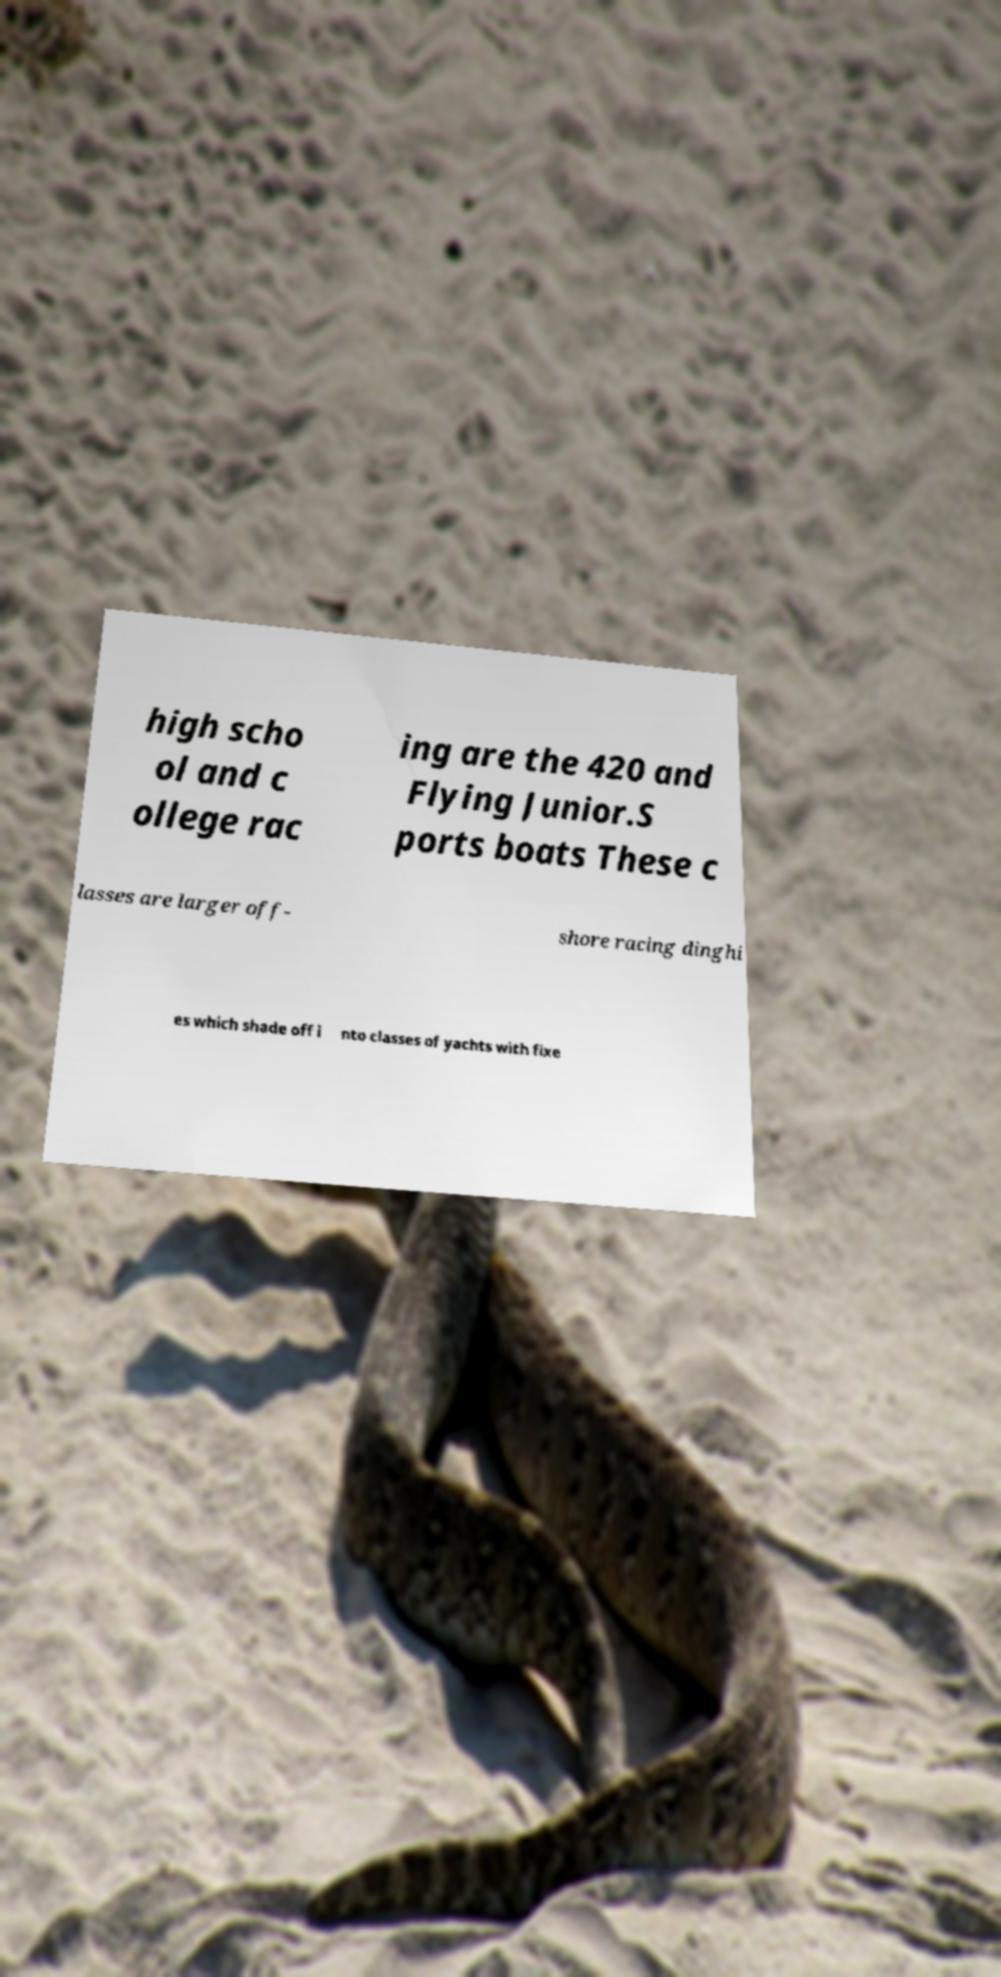What messages or text are displayed in this image? I need them in a readable, typed format. high scho ol and c ollege rac ing are the 420 and Flying Junior.S ports boats These c lasses are larger off- shore racing dinghi es which shade off i nto classes of yachts with fixe 